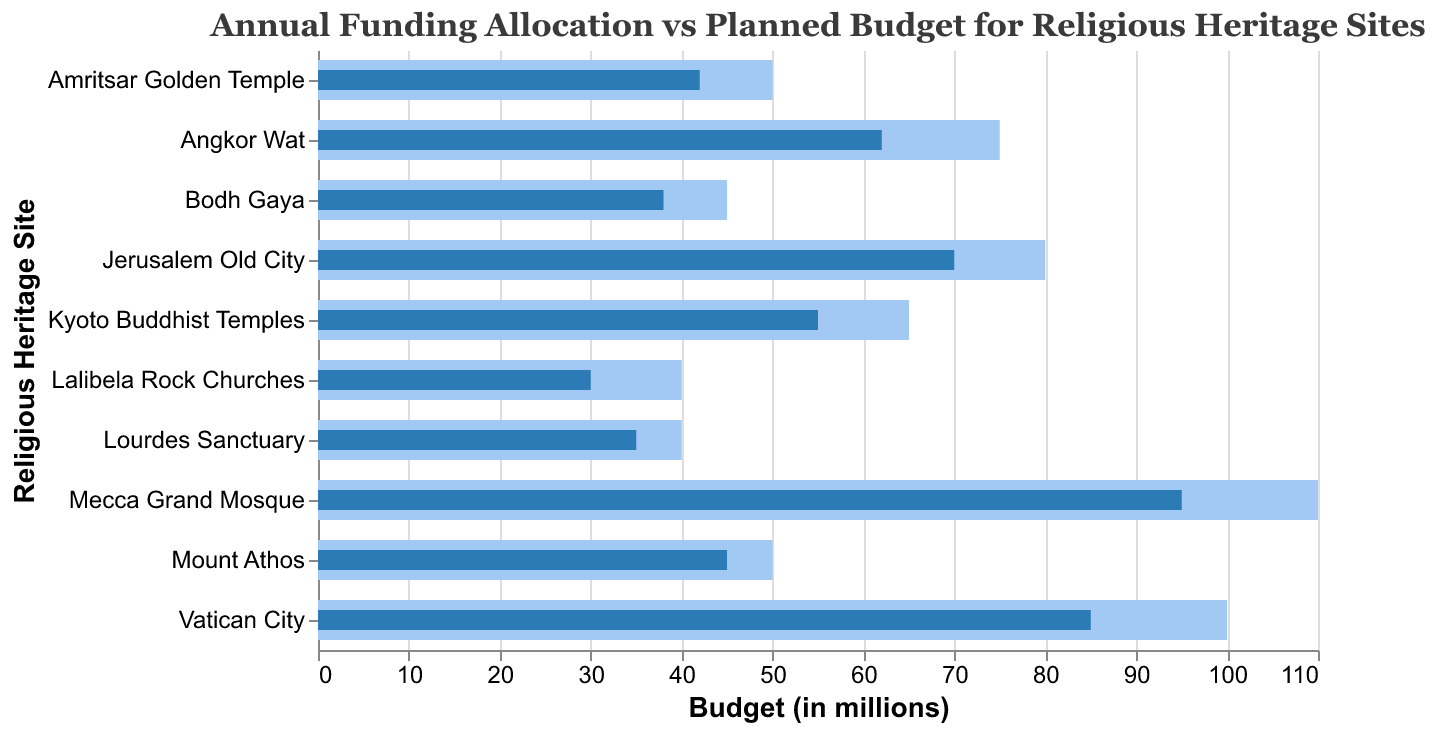What is the title of the chart? The title is usually positioned at the top of the chart and provides a summary of what the chart is about. In this case, the chart title is stated.
Answer: Annual Funding Allocation vs Planned Budget for Religious Heritage Sites How many religious heritage sites are represented in the chart? Count the number of unique sites listed on the vertical axis of the chart. Each bar represents a site.
Answer: 10 Which site has the highest planned budget? Look at the length of the bars corresponding to the "Planned" values and find the longest one.
Answer: Mecca Grand Mosque What is the difference between the allocated and planned budgets for Vatican City? Identify the "Allocated" and "Planned" values for the Vatican City, then subtract the allocated budget from the planned budget. The planned is 100 and the allocated is 85. So, the difference is
Answer: 15 Which site has the smallest difference between its allocated and planned budgets? Calculate the difference for each site by subtracting the allocated budget from the planned budget, then compare these differences to find the smallest one.
Answer: Mount Athos Are there any sites where the allocated budget is more than 90% of the planned budget? Calculate 90% of the planned budget for each site and compare it to the allocated budget to see if any allocated budgets meet or exceed this amount. Mecca Grand Mosque’s planned budget is 110; 90% of 110 is 99. The allocated budget is 95, which does not exceed 99. The Vatican City’s planned budget is 100; 90% of 100 is 90. The allocated budget is 85, which does not exceed 90. Continue this process for each site. No site meets this criterion.
Answer: No Which site has the highest shortfall in terms of allocated versus planned budget? Calculate the difference between allocated and planned budgets for each site and determine which is the largest.
Answer: Mecca Grand Mosque How does the allocated budget for Lalibela Rock Churches compare to the planned budget? Identify the "Allocated" and "Planned" values for Lalibela Rock Churches and directly compare them. The allocated budget (30) is less than the planned budget (40).
Answer: Less by 10 What is the total planned budget for all the sites combined? Sum up the "Planned" values for all listed sites: 100 + 75 + 50 + 45 + 80 + 40 + 110 + 65 + 50 + 40.
Answer: 655 How many sites have an allocated budget that is less than $50 million? Count the number of bars representing the "Allocated" values that are less than 50. These bars are shorter in length: Mount Athos (45), Bodh Gaya (38), Lalibela Rock Churches (30), Amritsar Golden Temple (42), Lourdes Sanctuary (35), totaling 5 sites.
Answer: 5 